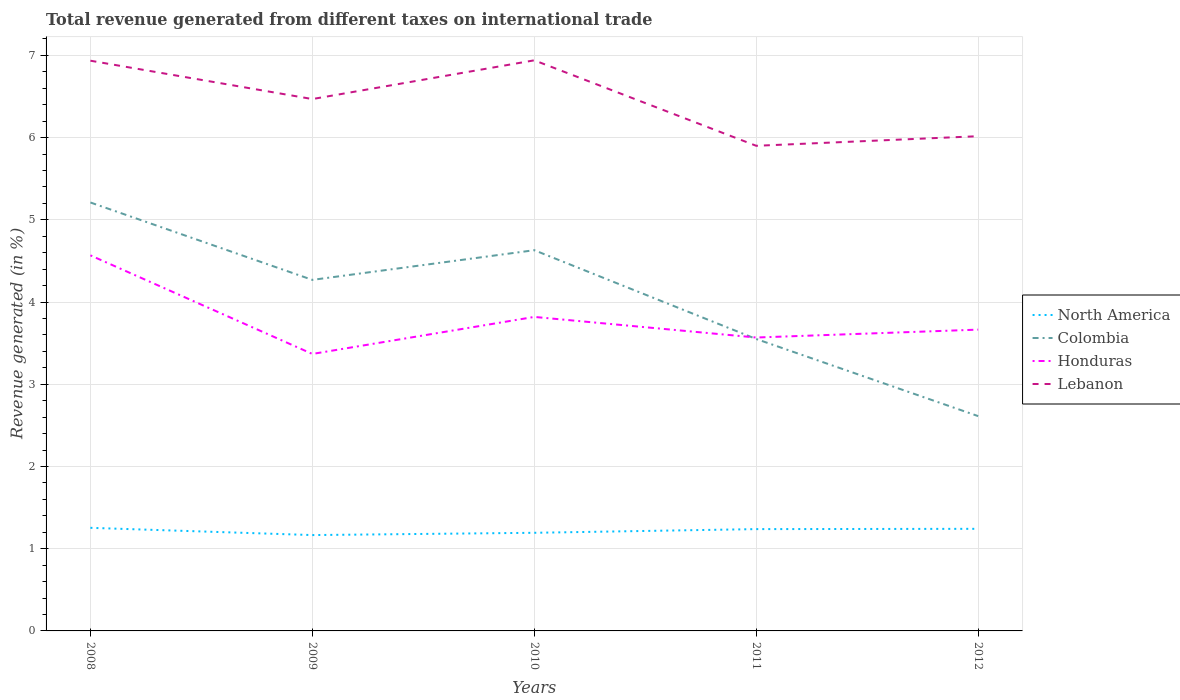Is the number of lines equal to the number of legend labels?
Keep it short and to the point. Yes. Across all years, what is the maximum total revenue generated in North America?
Offer a terse response. 1.17. What is the total total revenue generated in Honduras in the graph?
Your answer should be very brief. 1.2. What is the difference between the highest and the second highest total revenue generated in Lebanon?
Provide a short and direct response. 1.04. Is the total revenue generated in Colombia strictly greater than the total revenue generated in Lebanon over the years?
Offer a terse response. Yes. How many years are there in the graph?
Give a very brief answer. 5. What is the difference between two consecutive major ticks on the Y-axis?
Offer a terse response. 1. Are the values on the major ticks of Y-axis written in scientific E-notation?
Ensure brevity in your answer.  No. Does the graph contain grids?
Offer a very short reply. Yes. How many legend labels are there?
Give a very brief answer. 4. What is the title of the graph?
Offer a very short reply. Total revenue generated from different taxes on international trade. Does "Montenegro" appear as one of the legend labels in the graph?
Give a very brief answer. No. What is the label or title of the X-axis?
Provide a succinct answer. Years. What is the label or title of the Y-axis?
Keep it short and to the point. Revenue generated (in %). What is the Revenue generated (in %) in North America in 2008?
Provide a succinct answer. 1.25. What is the Revenue generated (in %) in Colombia in 2008?
Your response must be concise. 5.21. What is the Revenue generated (in %) of Honduras in 2008?
Offer a very short reply. 4.57. What is the Revenue generated (in %) in Lebanon in 2008?
Your response must be concise. 6.93. What is the Revenue generated (in %) of North America in 2009?
Offer a very short reply. 1.17. What is the Revenue generated (in %) in Colombia in 2009?
Offer a terse response. 4.27. What is the Revenue generated (in %) in Honduras in 2009?
Offer a terse response. 3.37. What is the Revenue generated (in %) of Lebanon in 2009?
Keep it short and to the point. 6.47. What is the Revenue generated (in %) in North America in 2010?
Give a very brief answer. 1.19. What is the Revenue generated (in %) of Colombia in 2010?
Provide a short and direct response. 4.63. What is the Revenue generated (in %) in Honduras in 2010?
Keep it short and to the point. 3.82. What is the Revenue generated (in %) in Lebanon in 2010?
Keep it short and to the point. 6.94. What is the Revenue generated (in %) of North America in 2011?
Offer a very short reply. 1.24. What is the Revenue generated (in %) in Colombia in 2011?
Offer a terse response. 3.55. What is the Revenue generated (in %) of Honduras in 2011?
Ensure brevity in your answer.  3.57. What is the Revenue generated (in %) in Lebanon in 2011?
Give a very brief answer. 5.9. What is the Revenue generated (in %) in North America in 2012?
Offer a very short reply. 1.24. What is the Revenue generated (in %) in Colombia in 2012?
Make the answer very short. 2.61. What is the Revenue generated (in %) in Honduras in 2012?
Your answer should be compact. 3.66. What is the Revenue generated (in %) of Lebanon in 2012?
Your answer should be compact. 6.02. Across all years, what is the maximum Revenue generated (in %) of North America?
Ensure brevity in your answer.  1.25. Across all years, what is the maximum Revenue generated (in %) of Colombia?
Your answer should be compact. 5.21. Across all years, what is the maximum Revenue generated (in %) in Honduras?
Provide a succinct answer. 4.57. Across all years, what is the maximum Revenue generated (in %) of Lebanon?
Offer a terse response. 6.94. Across all years, what is the minimum Revenue generated (in %) in North America?
Your answer should be very brief. 1.17. Across all years, what is the minimum Revenue generated (in %) in Colombia?
Offer a terse response. 2.61. Across all years, what is the minimum Revenue generated (in %) of Honduras?
Give a very brief answer. 3.37. Across all years, what is the minimum Revenue generated (in %) of Lebanon?
Your answer should be very brief. 5.9. What is the total Revenue generated (in %) in North America in the graph?
Offer a terse response. 6.09. What is the total Revenue generated (in %) of Colombia in the graph?
Offer a terse response. 20.27. What is the total Revenue generated (in %) in Honduras in the graph?
Give a very brief answer. 18.99. What is the total Revenue generated (in %) in Lebanon in the graph?
Your answer should be compact. 32.26. What is the difference between the Revenue generated (in %) in North America in 2008 and that in 2009?
Ensure brevity in your answer.  0.09. What is the difference between the Revenue generated (in %) of Colombia in 2008 and that in 2009?
Your response must be concise. 0.94. What is the difference between the Revenue generated (in %) of Honduras in 2008 and that in 2009?
Offer a terse response. 1.2. What is the difference between the Revenue generated (in %) in Lebanon in 2008 and that in 2009?
Offer a very short reply. 0.47. What is the difference between the Revenue generated (in %) of North America in 2008 and that in 2010?
Provide a succinct answer. 0.06. What is the difference between the Revenue generated (in %) of Colombia in 2008 and that in 2010?
Your answer should be compact. 0.58. What is the difference between the Revenue generated (in %) of Honduras in 2008 and that in 2010?
Give a very brief answer. 0.75. What is the difference between the Revenue generated (in %) in Lebanon in 2008 and that in 2010?
Keep it short and to the point. -0. What is the difference between the Revenue generated (in %) of North America in 2008 and that in 2011?
Offer a terse response. 0.02. What is the difference between the Revenue generated (in %) of Colombia in 2008 and that in 2011?
Provide a succinct answer. 1.66. What is the difference between the Revenue generated (in %) of Honduras in 2008 and that in 2011?
Keep it short and to the point. 1. What is the difference between the Revenue generated (in %) of Lebanon in 2008 and that in 2011?
Your answer should be very brief. 1.03. What is the difference between the Revenue generated (in %) of North America in 2008 and that in 2012?
Your answer should be compact. 0.01. What is the difference between the Revenue generated (in %) in Colombia in 2008 and that in 2012?
Make the answer very short. 2.6. What is the difference between the Revenue generated (in %) in Honduras in 2008 and that in 2012?
Offer a very short reply. 0.9. What is the difference between the Revenue generated (in %) in Lebanon in 2008 and that in 2012?
Provide a succinct answer. 0.92. What is the difference between the Revenue generated (in %) in North America in 2009 and that in 2010?
Provide a short and direct response. -0.03. What is the difference between the Revenue generated (in %) in Colombia in 2009 and that in 2010?
Offer a terse response. -0.36. What is the difference between the Revenue generated (in %) of Honduras in 2009 and that in 2010?
Your answer should be compact. -0.45. What is the difference between the Revenue generated (in %) in Lebanon in 2009 and that in 2010?
Ensure brevity in your answer.  -0.47. What is the difference between the Revenue generated (in %) in North America in 2009 and that in 2011?
Provide a succinct answer. -0.07. What is the difference between the Revenue generated (in %) of Colombia in 2009 and that in 2011?
Your response must be concise. 0.72. What is the difference between the Revenue generated (in %) of Honduras in 2009 and that in 2011?
Your answer should be very brief. -0.2. What is the difference between the Revenue generated (in %) of Lebanon in 2009 and that in 2011?
Offer a very short reply. 0.57. What is the difference between the Revenue generated (in %) in North America in 2009 and that in 2012?
Provide a short and direct response. -0.08. What is the difference between the Revenue generated (in %) in Colombia in 2009 and that in 2012?
Provide a succinct answer. 1.66. What is the difference between the Revenue generated (in %) in Honduras in 2009 and that in 2012?
Offer a terse response. -0.3. What is the difference between the Revenue generated (in %) of Lebanon in 2009 and that in 2012?
Offer a terse response. 0.45. What is the difference between the Revenue generated (in %) in North America in 2010 and that in 2011?
Your answer should be very brief. -0.04. What is the difference between the Revenue generated (in %) in Colombia in 2010 and that in 2011?
Offer a terse response. 1.08. What is the difference between the Revenue generated (in %) in Honduras in 2010 and that in 2011?
Offer a very short reply. 0.25. What is the difference between the Revenue generated (in %) of Lebanon in 2010 and that in 2011?
Make the answer very short. 1.04. What is the difference between the Revenue generated (in %) of North America in 2010 and that in 2012?
Keep it short and to the point. -0.05. What is the difference between the Revenue generated (in %) of Colombia in 2010 and that in 2012?
Ensure brevity in your answer.  2.02. What is the difference between the Revenue generated (in %) in Honduras in 2010 and that in 2012?
Give a very brief answer. 0.15. What is the difference between the Revenue generated (in %) of Lebanon in 2010 and that in 2012?
Offer a terse response. 0.92. What is the difference between the Revenue generated (in %) of North America in 2011 and that in 2012?
Keep it short and to the point. -0. What is the difference between the Revenue generated (in %) of Colombia in 2011 and that in 2012?
Keep it short and to the point. 0.94. What is the difference between the Revenue generated (in %) in Honduras in 2011 and that in 2012?
Make the answer very short. -0.1. What is the difference between the Revenue generated (in %) of Lebanon in 2011 and that in 2012?
Make the answer very short. -0.12. What is the difference between the Revenue generated (in %) of North America in 2008 and the Revenue generated (in %) of Colombia in 2009?
Provide a short and direct response. -3.02. What is the difference between the Revenue generated (in %) of North America in 2008 and the Revenue generated (in %) of Honduras in 2009?
Provide a succinct answer. -2.11. What is the difference between the Revenue generated (in %) in North America in 2008 and the Revenue generated (in %) in Lebanon in 2009?
Make the answer very short. -5.21. What is the difference between the Revenue generated (in %) in Colombia in 2008 and the Revenue generated (in %) in Honduras in 2009?
Make the answer very short. 1.84. What is the difference between the Revenue generated (in %) of Colombia in 2008 and the Revenue generated (in %) of Lebanon in 2009?
Keep it short and to the point. -1.26. What is the difference between the Revenue generated (in %) of Honduras in 2008 and the Revenue generated (in %) of Lebanon in 2009?
Offer a very short reply. -1.9. What is the difference between the Revenue generated (in %) in North America in 2008 and the Revenue generated (in %) in Colombia in 2010?
Offer a very short reply. -3.38. What is the difference between the Revenue generated (in %) of North America in 2008 and the Revenue generated (in %) of Honduras in 2010?
Ensure brevity in your answer.  -2.56. What is the difference between the Revenue generated (in %) of North America in 2008 and the Revenue generated (in %) of Lebanon in 2010?
Provide a short and direct response. -5.69. What is the difference between the Revenue generated (in %) in Colombia in 2008 and the Revenue generated (in %) in Honduras in 2010?
Provide a short and direct response. 1.39. What is the difference between the Revenue generated (in %) of Colombia in 2008 and the Revenue generated (in %) of Lebanon in 2010?
Your answer should be compact. -1.73. What is the difference between the Revenue generated (in %) in Honduras in 2008 and the Revenue generated (in %) in Lebanon in 2010?
Your answer should be very brief. -2.37. What is the difference between the Revenue generated (in %) in North America in 2008 and the Revenue generated (in %) in Colombia in 2011?
Ensure brevity in your answer.  -2.3. What is the difference between the Revenue generated (in %) in North America in 2008 and the Revenue generated (in %) in Honduras in 2011?
Offer a very short reply. -2.31. What is the difference between the Revenue generated (in %) of North America in 2008 and the Revenue generated (in %) of Lebanon in 2011?
Make the answer very short. -4.65. What is the difference between the Revenue generated (in %) of Colombia in 2008 and the Revenue generated (in %) of Honduras in 2011?
Offer a terse response. 1.64. What is the difference between the Revenue generated (in %) in Colombia in 2008 and the Revenue generated (in %) in Lebanon in 2011?
Your answer should be very brief. -0.69. What is the difference between the Revenue generated (in %) in Honduras in 2008 and the Revenue generated (in %) in Lebanon in 2011?
Offer a terse response. -1.33. What is the difference between the Revenue generated (in %) of North America in 2008 and the Revenue generated (in %) of Colombia in 2012?
Your answer should be very brief. -1.36. What is the difference between the Revenue generated (in %) of North America in 2008 and the Revenue generated (in %) of Honduras in 2012?
Provide a succinct answer. -2.41. What is the difference between the Revenue generated (in %) in North America in 2008 and the Revenue generated (in %) in Lebanon in 2012?
Make the answer very short. -4.76. What is the difference between the Revenue generated (in %) in Colombia in 2008 and the Revenue generated (in %) in Honduras in 2012?
Your response must be concise. 1.55. What is the difference between the Revenue generated (in %) of Colombia in 2008 and the Revenue generated (in %) of Lebanon in 2012?
Give a very brief answer. -0.81. What is the difference between the Revenue generated (in %) of Honduras in 2008 and the Revenue generated (in %) of Lebanon in 2012?
Offer a very short reply. -1.45. What is the difference between the Revenue generated (in %) in North America in 2009 and the Revenue generated (in %) in Colombia in 2010?
Give a very brief answer. -3.46. What is the difference between the Revenue generated (in %) of North America in 2009 and the Revenue generated (in %) of Honduras in 2010?
Give a very brief answer. -2.65. What is the difference between the Revenue generated (in %) in North America in 2009 and the Revenue generated (in %) in Lebanon in 2010?
Your answer should be very brief. -5.77. What is the difference between the Revenue generated (in %) in Colombia in 2009 and the Revenue generated (in %) in Honduras in 2010?
Offer a terse response. 0.45. What is the difference between the Revenue generated (in %) of Colombia in 2009 and the Revenue generated (in %) of Lebanon in 2010?
Ensure brevity in your answer.  -2.67. What is the difference between the Revenue generated (in %) of Honduras in 2009 and the Revenue generated (in %) of Lebanon in 2010?
Ensure brevity in your answer.  -3.57. What is the difference between the Revenue generated (in %) in North America in 2009 and the Revenue generated (in %) in Colombia in 2011?
Offer a very short reply. -2.38. What is the difference between the Revenue generated (in %) in North America in 2009 and the Revenue generated (in %) in Honduras in 2011?
Your answer should be compact. -2.4. What is the difference between the Revenue generated (in %) in North America in 2009 and the Revenue generated (in %) in Lebanon in 2011?
Ensure brevity in your answer.  -4.73. What is the difference between the Revenue generated (in %) in Colombia in 2009 and the Revenue generated (in %) in Honduras in 2011?
Offer a very short reply. 0.7. What is the difference between the Revenue generated (in %) in Colombia in 2009 and the Revenue generated (in %) in Lebanon in 2011?
Offer a very short reply. -1.63. What is the difference between the Revenue generated (in %) of Honduras in 2009 and the Revenue generated (in %) of Lebanon in 2011?
Your response must be concise. -2.53. What is the difference between the Revenue generated (in %) of North America in 2009 and the Revenue generated (in %) of Colombia in 2012?
Give a very brief answer. -1.45. What is the difference between the Revenue generated (in %) of North America in 2009 and the Revenue generated (in %) of Honduras in 2012?
Offer a terse response. -2.5. What is the difference between the Revenue generated (in %) of North America in 2009 and the Revenue generated (in %) of Lebanon in 2012?
Your answer should be compact. -4.85. What is the difference between the Revenue generated (in %) in Colombia in 2009 and the Revenue generated (in %) in Honduras in 2012?
Your answer should be compact. 0.6. What is the difference between the Revenue generated (in %) of Colombia in 2009 and the Revenue generated (in %) of Lebanon in 2012?
Make the answer very short. -1.75. What is the difference between the Revenue generated (in %) in Honduras in 2009 and the Revenue generated (in %) in Lebanon in 2012?
Make the answer very short. -2.65. What is the difference between the Revenue generated (in %) of North America in 2010 and the Revenue generated (in %) of Colombia in 2011?
Give a very brief answer. -2.36. What is the difference between the Revenue generated (in %) of North America in 2010 and the Revenue generated (in %) of Honduras in 2011?
Your response must be concise. -2.37. What is the difference between the Revenue generated (in %) of North America in 2010 and the Revenue generated (in %) of Lebanon in 2011?
Give a very brief answer. -4.71. What is the difference between the Revenue generated (in %) of Colombia in 2010 and the Revenue generated (in %) of Honduras in 2011?
Provide a succinct answer. 1.06. What is the difference between the Revenue generated (in %) in Colombia in 2010 and the Revenue generated (in %) in Lebanon in 2011?
Your answer should be very brief. -1.27. What is the difference between the Revenue generated (in %) of Honduras in 2010 and the Revenue generated (in %) of Lebanon in 2011?
Provide a succinct answer. -2.08. What is the difference between the Revenue generated (in %) in North America in 2010 and the Revenue generated (in %) in Colombia in 2012?
Provide a short and direct response. -1.42. What is the difference between the Revenue generated (in %) in North America in 2010 and the Revenue generated (in %) in Honduras in 2012?
Provide a succinct answer. -2.47. What is the difference between the Revenue generated (in %) in North America in 2010 and the Revenue generated (in %) in Lebanon in 2012?
Ensure brevity in your answer.  -4.82. What is the difference between the Revenue generated (in %) of Colombia in 2010 and the Revenue generated (in %) of Honduras in 2012?
Your answer should be very brief. 0.97. What is the difference between the Revenue generated (in %) in Colombia in 2010 and the Revenue generated (in %) in Lebanon in 2012?
Ensure brevity in your answer.  -1.39. What is the difference between the Revenue generated (in %) in Honduras in 2010 and the Revenue generated (in %) in Lebanon in 2012?
Your answer should be compact. -2.2. What is the difference between the Revenue generated (in %) of North America in 2011 and the Revenue generated (in %) of Colombia in 2012?
Give a very brief answer. -1.37. What is the difference between the Revenue generated (in %) of North America in 2011 and the Revenue generated (in %) of Honduras in 2012?
Your answer should be very brief. -2.43. What is the difference between the Revenue generated (in %) of North America in 2011 and the Revenue generated (in %) of Lebanon in 2012?
Your response must be concise. -4.78. What is the difference between the Revenue generated (in %) of Colombia in 2011 and the Revenue generated (in %) of Honduras in 2012?
Keep it short and to the point. -0.11. What is the difference between the Revenue generated (in %) in Colombia in 2011 and the Revenue generated (in %) in Lebanon in 2012?
Provide a succinct answer. -2.47. What is the difference between the Revenue generated (in %) of Honduras in 2011 and the Revenue generated (in %) of Lebanon in 2012?
Your answer should be very brief. -2.45. What is the average Revenue generated (in %) of North America per year?
Keep it short and to the point. 1.22. What is the average Revenue generated (in %) of Colombia per year?
Make the answer very short. 4.05. What is the average Revenue generated (in %) in Honduras per year?
Ensure brevity in your answer.  3.8. What is the average Revenue generated (in %) of Lebanon per year?
Your answer should be compact. 6.45. In the year 2008, what is the difference between the Revenue generated (in %) in North America and Revenue generated (in %) in Colombia?
Provide a short and direct response. -3.96. In the year 2008, what is the difference between the Revenue generated (in %) in North America and Revenue generated (in %) in Honduras?
Offer a terse response. -3.31. In the year 2008, what is the difference between the Revenue generated (in %) in North America and Revenue generated (in %) in Lebanon?
Provide a succinct answer. -5.68. In the year 2008, what is the difference between the Revenue generated (in %) in Colombia and Revenue generated (in %) in Honduras?
Offer a very short reply. 0.64. In the year 2008, what is the difference between the Revenue generated (in %) in Colombia and Revenue generated (in %) in Lebanon?
Your answer should be compact. -1.72. In the year 2008, what is the difference between the Revenue generated (in %) in Honduras and Revenue generated (in %) in Lebanon?
Make the answer very short. -2.37. In the year 2009, what is the difference between the Revenue generated (in %) in North America and Revenue generated (in %) in Colombia?
Keep it short and to the point. -3.1. In the year 2009, what is the difference between the Revenue generated (in %) of North America and Revenue generated (in %) of Honduras?
Offer a terse response. -2.2. In the year 2009, what is the difference between the Revenue generated (in %) of North America and Revenue generated (in %) of Lebanon?
Make the answer very short. -5.3. In the year 2009, what is the difference between the Revenue generated (in %) in Colombia and Revenue generated (in %) in Honduras?
Give a very brief answer. 0.9. In the year 2009, what is the difference between the Revenue generated (in %) in Colombia and Revenue generated (in %) in Lebanon?
Provide a short and direct response. -2.2. In the year 2009, what is the difference between the Revenue generated (in %) in Honduras and Revenue generated (in %) in Lebanon?
Ensure brevity in your answer.  -3.1. In the year 2010, what is the difference between the Revenue generated (in %) in North America and Revenue generated (in %) in Colombia?
Make the answer very short. -3.44. In the year 2010, what is the difference between the Revenue generated (in %) of North America and Revenue generated (in %) of Honduras?
Offer a very short reply. -2.63. In the year 2010, what is the difference between the Revenue generated (in %) of North America and Revenue generated (in %) of Lebanon?
Your answer should be compact. -5.75. In the year 2010, what is the difference between the Revenue generated (in %) in Colombia and Revenue generated (in %) in Honduras?
Your response must be concise. 0.81. In the year 2010, what is the difference between the Revenue generated (in %) of Colombia and Revenue generated (in %) of Lebanon?
Your answer should be very brief. -2.31. In the year 2010, what is the difference between the Revenue generated (in %) in Honduras and Revenue generated (in %) in Lebanon?
Give a very brief answer. -3.12. In the year 2011, what is the difference between the Revenue generated (in %) of North America and Revenue generated (in %) of Colombia?
Offer a terse response. -2.31. In the year 2011, what is the difference between the Revenue generated (in %) of North America and Revenue generated (in %) of Honduras?
Keep it short and to the point. -2.33. In the year 2011, what is the difference between the Revenue generated (in %) of North America and Revenue generated (in %) of Lebanon?
Your answer should be very brief. -4.66. In the year 2011, what is the difference between the Revenue generated (in %) of Colombia and Revenue generated (in %) of Honduras?
Give a very brief answer. -0.02. In the year 2011, what is the difference between the Revenue generated (in %) in Colombia and Revenue generated (in %) in Lebanon?
Provide a succinct answer. -2.35. In the year 2011, what is the difference between the Revenue generated (in %) in Honduras and Revenue generated (in %) in Lebanon?
Your response must be concise. -2.33. In the year 2012, what is the difference between the Revenue generated (in %) of North America and Revenue generated (in %) of Colombia?
Provide a succinct answer. -1.37. In the year 2012, what is the difference between the Revenue generated (in %) of North America and Revenue generated (in %) of Honduras?
Offer a terse response. -2.42. In the year 2012, what is the difference between the Revenue generated (in %) of North America and Revenue generated (in %) of Lebanon?
Your answer should be very brief. -4.78. In the year 2012, what is the difference between the Revenue generated (in %) in Colombia and Revenue generated (in %) in Honduras?
Offer a terse response. -1.05. In the year 2012, what is the difference between the Revenue generated (in %) in Colombia and Revenue generated (in %) in Lebanon?
Your answer should be very brief. -3.4. In the year 2012, what is the difference between the Revenue generated (in %) in Honduras and Revenue generated (in %) in Lebanon?
Offer a very short reply. -2.35. What is the ratio of the Revenue generated (in %) in North America in 2008 to that in 2009?
Offer a very short reply. 1.08. What is the ratio of the Revenue generated (in %) of Colombia in 2008 to that in 2009?
Keep it short and to the point. 1.22. What is the ratio of the Revenue generated (in %) in Honduras in 2008 to that in 2009?
Provide a short and direct response. 1.36. What is the ratio of the Revenue generated (in %) of Lebanon in 2008 to that in 2009?
Ensure brevity in your answer.  1.07. What is the ratio of the Revenue generated (in %) of North America in 2008 to that in 2010?
Give a very brief answer. 1.05. What is the ratio of the Revenue generated (in %) in Colombia in 2008 to that in 2010?
Provide a succinct answer. 1.13. What is the ratio of the Revenue generated (in %) of Honduras in 2008 to that in 2010?
Your answer should be compact. 1.2. What is the ratio of the Revenue generated (in %) in Lebanon in 2008 to that in 2010?
Ensure brevity in your answer.  1. What is the ratio of the Revenue generated (in %) of North America in 2008 to that in 2011?
Keep it short and to the point. 1.01. What is the ratio of the Revenue generated (in %) in Colombia in 2008 to that in 2011?
Your answer should be very brief. 1.47. What is the ratio of the Revenue generated (in %) of Honduras in 2008 to that in 2011?
Make the answer very short. 1.28. What is the ratio of the Revenue generated (in %) in Lebanon in 2008 to that in 2011?
Your answer should be compact. 1.18. What is the ratio of the Revenue generated (in %) in North America in 2008 to that in 2012?
Keep it short and to the point. 1.01. What is the ratio of the Revenue generated (in %) in Colombia in 2008 to that in 2012?
Your answer should be compact. 1.99. What is the ratio of the Revenue generated (in %) of Honduras in 2008 to that in 2012?
Give a very brief answer. 1.25. What is the ratio of the Revenue generated (in %) in Lebanon in 2008 to that in 2012?
Your answer should be compact. 1.15. What is the ratio of the Revenue generated (in %) in North America in 2009 to that in 2010?
Your answer should be compact. 0.98. What is the ratio of the Revenue generated (in %) of Colombia in 2009 to that in 2010?
Offer a very short reply. 0.92. What is the ratio of the Revenue generated (in %) in Honduras in 2009 to that in 2010?
Make the answer very short. 0.88. What is the ratio of the Revenue generated (in %) of Lebanon in 2009 to that in 2010?
Make the answer very short. 0.93. What is the ratio of the Revenue generated (in %) of North America in 2009 to that in 2011?
Provide a short and direct response. 0.94. What is the ratio of the Revenue generated (in %) in Colombia in 2009 to that in 2011?
Your answer should be compact. 1.2. What is the ratio of the Revenue generated (in %) in Honduras in 2009 to that in 2011?
Give a very brief answer. 0.94. What is the ratio of the Revenue generated (in %) of Lebanon in 2009 to that in 2011?
Make the answer very short. 1.1. What is the ratio of the Revenue generated (in %) in North America in 2009 to that in 2012?
Give a very brief answer. 0.94. What is the ratio of the Revenue generated (in %) in Colombia in 2009 to that in 2012?
Provide a succinct answer. 1.63. What is the ratio of the Revenue generated (in %) of Honduras in 2009 to that in 2012?
Offer a terse response. 0.92. What is the ratio of the Revenue generated (in %) of Lebanon in 2009 to that in 2012?
Provide a succinct answer. 1.08. What is the ratio of the Revenue generated (in %) of North America in 2010 to that in 2011?
Give a very brief answer. 0.96. What is the ratio of the Revenue generated (in %) of Colombia in 2010 to that in 2011?
Your answer should be very brief. 1.3. What is the ratio of the Revenue generated (in %) of Honduras in 2010 to that in 2011?
Your answer should be very brief. 1.07. What is the ratio of the Revenue generated (in %) of Lebanon in 2010 to that in 2011?
Offer a very short reply. 1.18. What is the ratio of the Revenue generated (in %) of North America in 2010 to that in 2012?
Give a very brief answer. 0.96. What is the ratio of the Revenue generated (in %) of Colombia in 2010 to that in 2012?
Your answer should be very brief. 1.77. What is the ratio of the Revenue generated (in %) of Honduras in 2010 to that in 2012?
Make the answer very short. 1.04. What is the ratio of the Revenue generated (in %) in Lebanon in 2010 to that in 2012?
Offer a very short reply. 1.15. What is the ratio of the Revenue generated (in %) in Colombia in 2011 to that in 2012?
Offer a terse response. 1.36. What is the ratio of the Revenue generated (in %) in Honduras in 2011 to that in 2012?
Provide a succinct answer. 0.97. What is the ratio of the Revenue generated (in %) of Lebanon in 2011 to that in 2012?
Provide a succinct answer. 0.98. What is the difference between the highest and the second highest Revenue generated (in %) of North America?
Offer a terse response. 0.01. What is the difference between the highest and the second highest Revenue generated (in %) of Colombia?
Keep it short and to the point. 0.58. What is the difference between the highest and the second highest Revenue generated (in %) in Honduras?
Provide a succinct answer. 0.75. What is the difference between the highest and the second highest Revenue generated (in %) in Lebanon?
Your response must be concise. 0. What is the difference between the highest and the lowest Revenue generated (in %) in North America?
Give a very brief answer. 0.09. What is the difference between the highest and the lowest Revenue generated (in %) of Colombia?
Your answer should be very brief. 2.6. What is the difference between the highest and the lowest Revenue generated (in %) in Honduras?
Offer a terse response. 1.2. What is the difference between the highest and the lowest Revenue generated (in %) in Lebanon?
Your response must be concise. 1.04. 